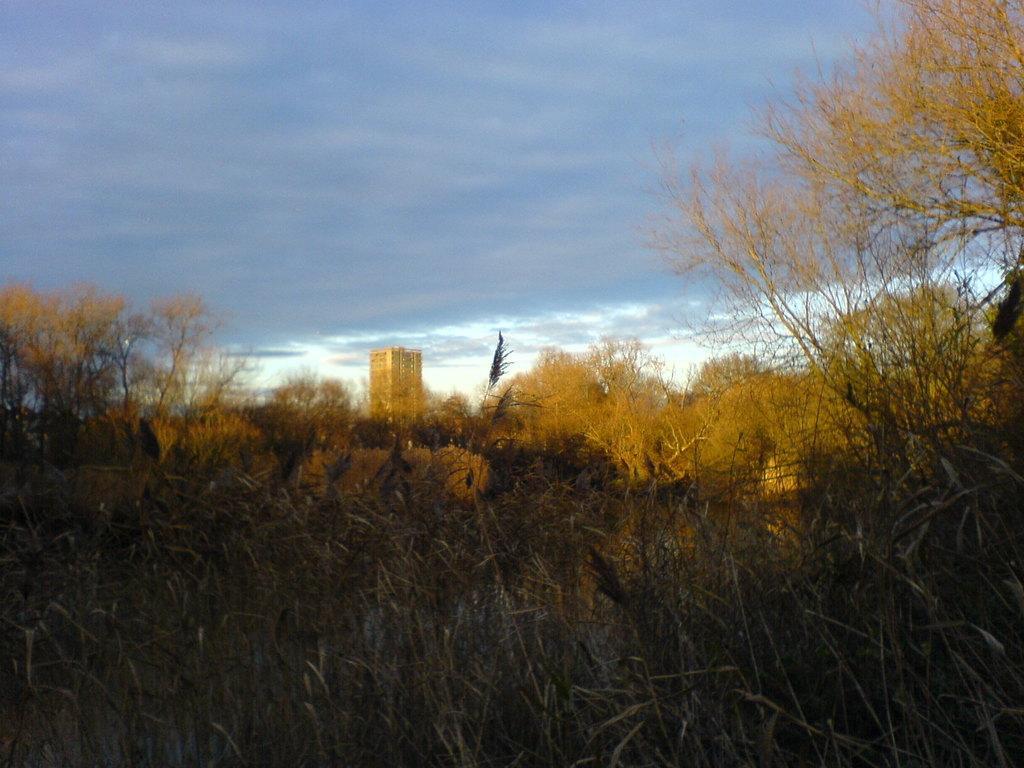How would you summarize this image in a sentence or two? In front of the image there is grass on the surface. In the background of the image there are trees and a building. At the top of the image there are clouds in the sky. 